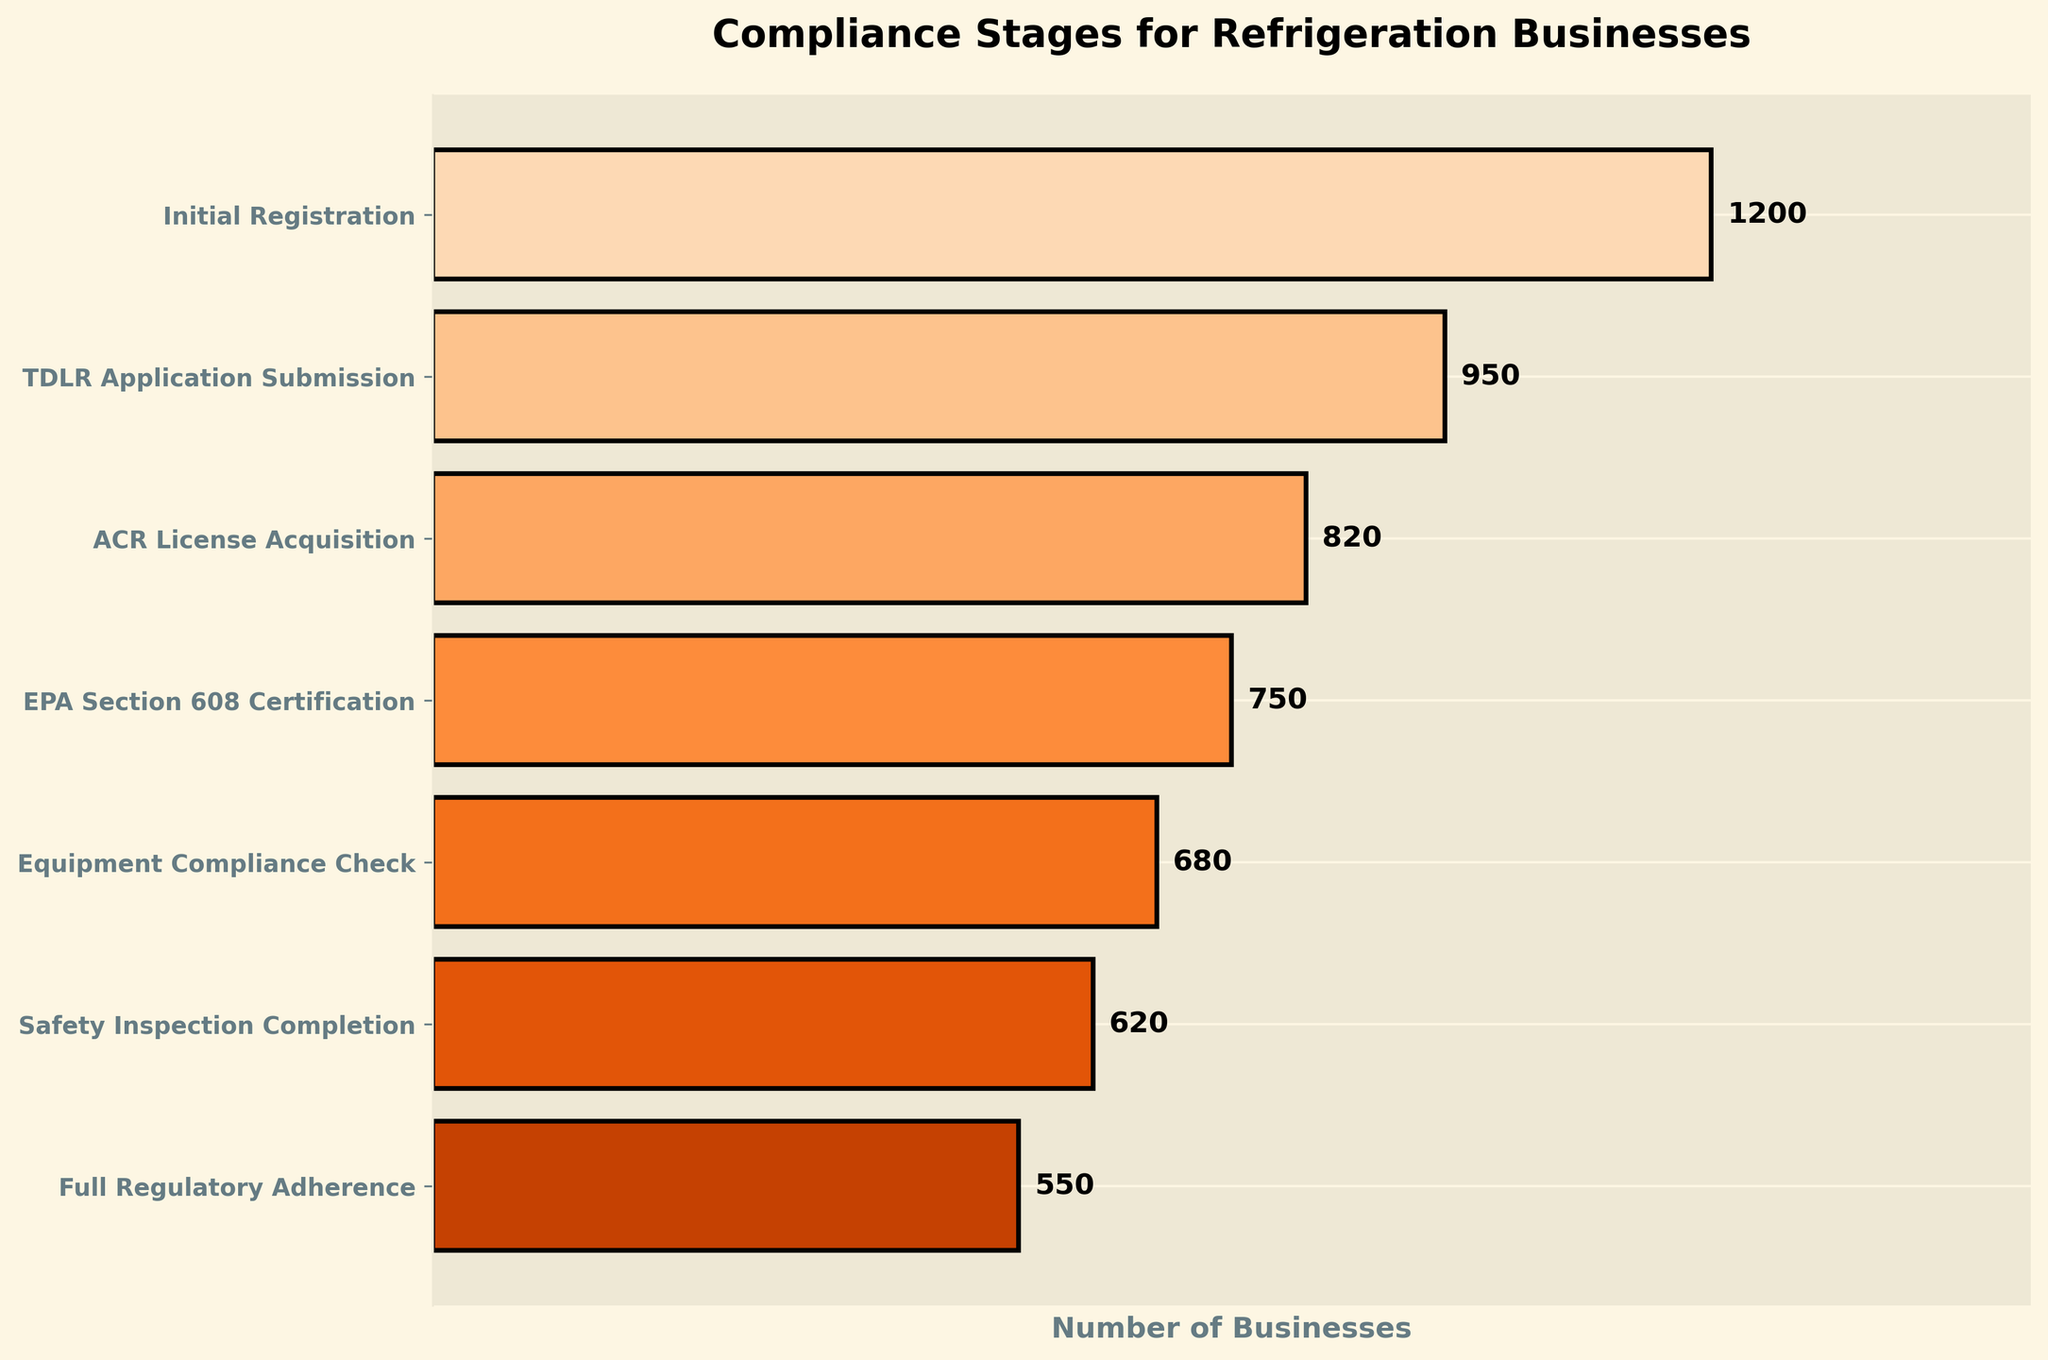How many stages are represented in the funnel chart? There are 7 stages represented in the funnel chart as indicated by the number of different entries appearing along the y-axis. Each stage represents a step in the compliance process.
Answer: 7 Which stage has the highest number of businesses? The stage with the highest number of businesses is the "Initial Registration" stage, as it has the widest section and a value of 1200.
Answer: Initial Registration By how much does the number of businesses decrease from the "TDLR Application Submission" stage to the "EPA Section 608 Certification" stage? The number of businesses at the "TDLR Application Submission" stage is 950, and at the "EPA Section 608 Certification" stage, it is 750. Therefore, the decrease is 950 - 750.
Answer: 200 Which stage shows the smallest number of businesses that have completed it? The "Full Regulatory Adherence" stage shows the smallest number of businesses that have completed it with a value of 550, indicating it is the narrowest section at the bottom of the chart.
Answer: Full Regulatory Adherence Compare the number of businesses between the "ACR License Acquisition" and "Safety Inspection Completion" stages. Which has more, and by how much? The "ACR License Acquisition" stage has 820 businesses, and the "Safety Inspection Completion" stage has 620 businesses. Therefore, the "ACR License Acquisition" stage has more businesses, and the difference is 820 - 620.
Answer: ACR License Acquisition by 200 What is the total number of businesses that have at least submitted the "TDLR Application Submission"? The total number of businesses that have at least submitted the "TDLR Application Submission" is the sum of all subsequent stages' values starting from this stage: 950 + 820 + 750 + 680 + 620 + 550.
Answer: 4370 What percentage of businesses that submitted the "TDLR Application Submission" stage reached the "Full Regulatory Adherence" stage? The number of businesses at the "TDLR Application Submission" stage is 950, and at "Full Regulatory Adherence" is 550. The percentage is calculated as (550 / 950) * 100.
Answer: 57.9% Which two stages have the closest number of businesses, and what is their difference? The "Equipment Compliance Check" stage has 680 businesses, and the "Safety Inspection Completion" stage has 620 businesses, making the difference 680 - 620.
Answer: Equipment Compliance Check and Safety Inspection Completion, 60 